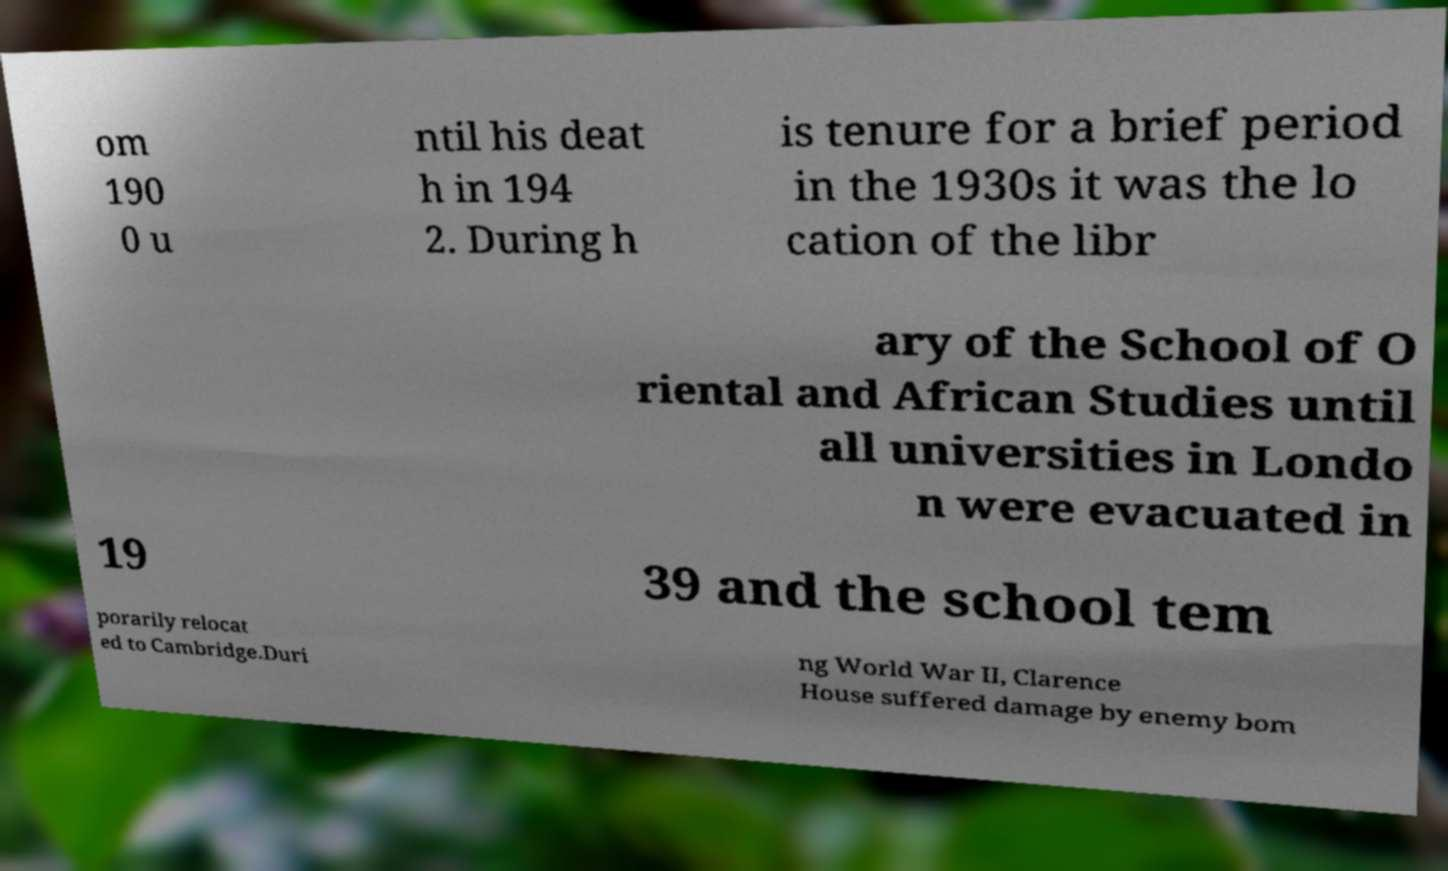Could you extract and type out the text from this image? om 190 0 u ntil his deat h in 194 2. During h is tenure for a brief period in the 1930s it was the lo cation of the libr ary of the School of O riental and African Studies until all universities in Londo n were evacuated in 19 39 and the school tem porarily relocat ed to Cambridge.Duri ng World War II, Clarence House suffered damage by enemy bom 